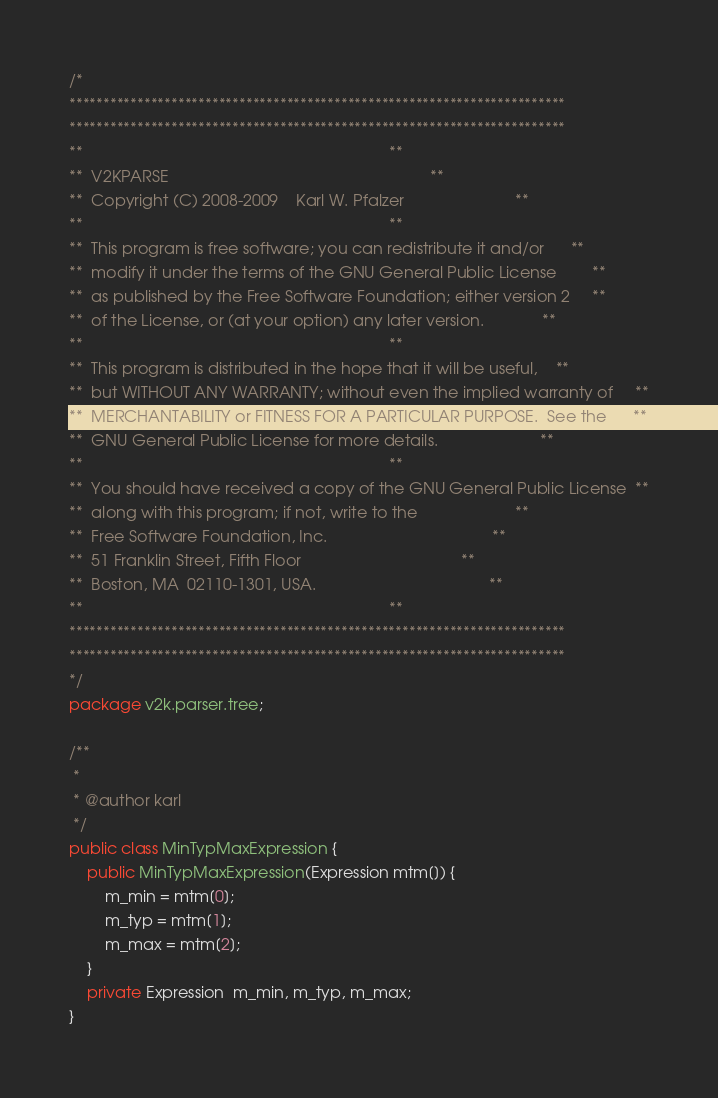Convert code to text. <code><loc_0><loc_0><loc_500><loc_500><_Java_>/*
*************************************************************************
*************************************************************************
**                                                                     **
**  V2KPARSE                                                           **
**  Copyright (C) 2008-2009    Karl W. Pfalzer                         **
**                                                                     **
**  This program is free software; you can redistribute it and/or      **
**  modify it under the terms of the GNU General Public License        **
**  as published by the Free Software Foundation; either version 2     **
**  of the License, or (at your option) any later version.             **
**                                                                     **
**  This program is distributed in the hope that it will be useful,    **
**  but WITHOUT ANY WARRANTY; without even the implied warranty of     **
**  MERCHANTABILITY or FITNESS FOR A PARTICULAR PURPOSE.  See the      **
**  GNU General Public License for more details.                       **
**                                                                     **
**  You should have received a copy of the GNU General Public License  **
**  along with this program; if not, write to the                      **
**  Free Software Foundation, Inc.                                     **
**  51 Franklin Street, Fifth Floor                                    **
**  Boston, MA  02110-1301, USA.                                       **
**                                                                     **
*************************************************************************
*************************************************************************
*/
package v2k.parser.tree;

/**
 *
 * @author karl
 */
public class MinTypMaxExpression {
    public MinTypMaxExpression(Expression mtm[]) {
        m_min = mtm[0];
        m_typ = mtm[1];
        m_max = mtm[2];
    }
    private Expression  m_min, m_typ, m_max;
}
</code> 